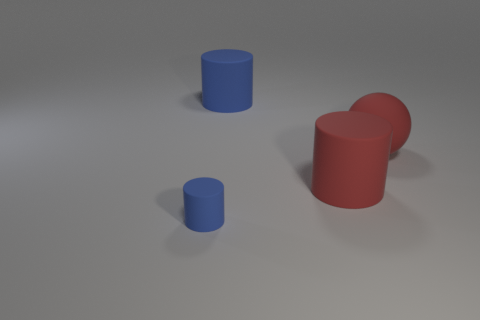Add 4 purple objects. How many objects exist? 8 Subtract all cylinders. How many objects are left? 1 Subtract 0 blue balls. How many objects are left? 4 Subtract all red objects. Subtract all brown shiny blocks. How many objects are left? 2 Add 1 red cylinders. How many red cylinders are left? 2 Add 2 rubber balls. How many rubber balls exist? 3 